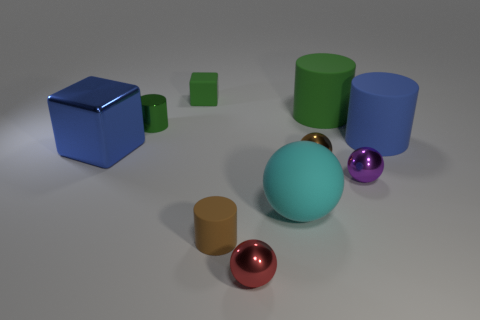Are there any purple balls behind the green cylinder that is left of the sphere in front of the cyan sphere?
Your response must be concise. No. There is a large blue thing that is on the right side of the small brown cylinder; is its shape the same as the purple thing?
Your answer should be compact. No. There is a tiny cylinder that is the same material as the large block; what is its color?
Keep it short and to the point. Green. What number of small purple spheres have the same material as the small red object?
Keep it short and to the point. 1. There is a shiny thing behind the thing to the left of the tiny cylinder behind the big metallic object; what is its color?
Your answer should be very brief. Green. Do the green rubber cylinder and the green matte cube have the same size?
Provide a succinct answer. No. Is there any other thing that has the same shape as the blue rubber object?
Offer a very short reply. Yes. How many objects are either tiny red objects that are in front of the large blue shiny object or purple objects?
Your answer should be compact. 2. Is the shape of the big blue matte object the same as the small red metallic thing?
Your answer should be very brief. No. How many other objects are there of the same size as the purple metal thing?
Your answer should be compact. 5. 